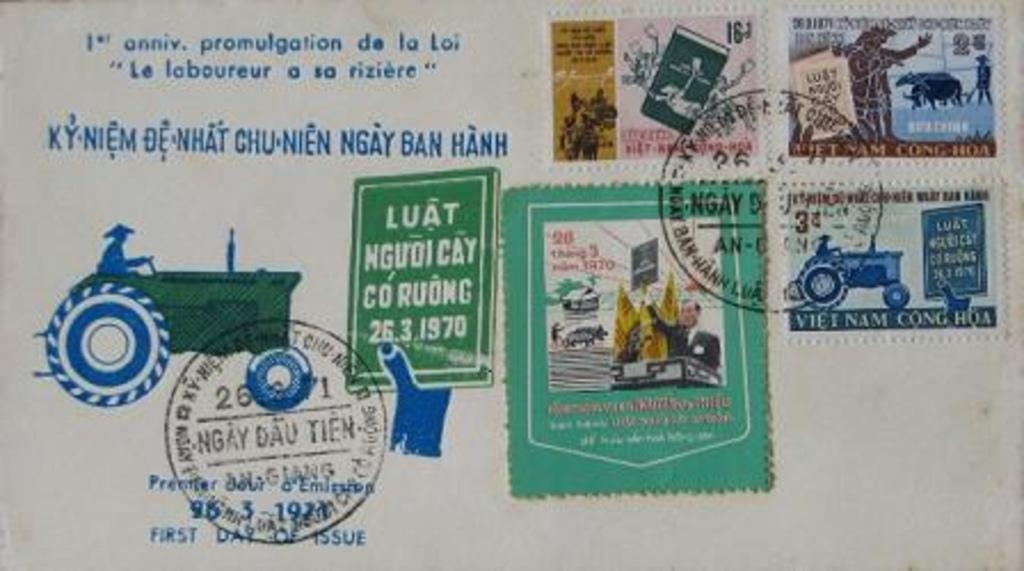What is the main object in the image? There is a postcard in the image. What can be found on the postcard? The postcard contains text and has stamps. What image is depicted on the postcard? There is a tractor image on the postcard. How many pizzas are shown on the postcard? There are no pizzas depicted on the postcard; it features a tractor image. Is there a bear visible on the postcard? There is no bear present on the postcard; it features a tractor image. 